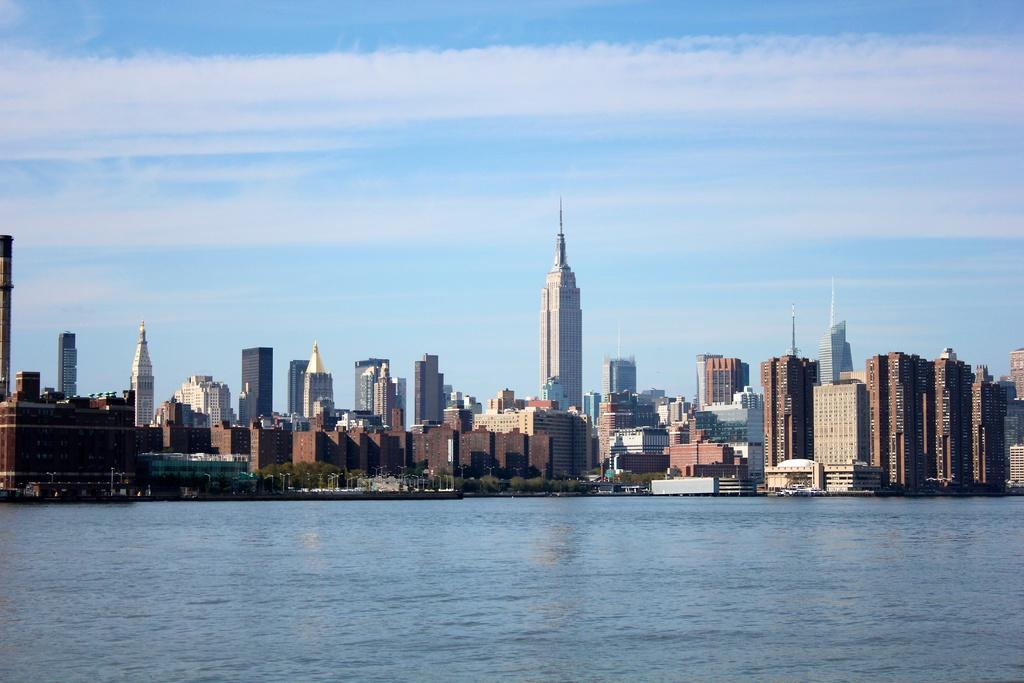What is the main element in the image? There is water in the image. What can be seen in the background of the image? There are trees and buildings in the background of the image. What is the color of the sky in the image? The sky is blue in the image. Are there any clouds visible in the sky? Yes, there are clouds in the sky in the image. How much payment is required to access the horse in the image? There is no horse present in the image, so no payment is required for access. 